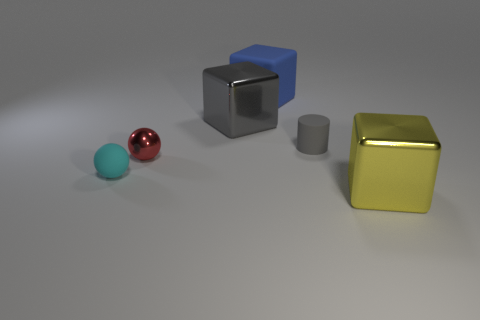Subtract all shiny blocks. How many blocks are left? 1 Add 3 red balls. How many objects exist? 9 Subtract all gray cubes. How many cubes are left? 2 Subtract all cylinders. How many objects are left? 5 Subtract all red cylinders. Subtract all red blocks. How many cylinders are left? 1 Subtract all yellow balls. How many yellow cylinders are left? 0 Subtract all red spheres. Subtract all big things. How many objects are left? 2 Add 3 gray cubes. How many gray cubes are left? 4 Add 3 purple things. How many purple things exist? 3 Subtract 0 brown spheres. How many objects are left? 6 